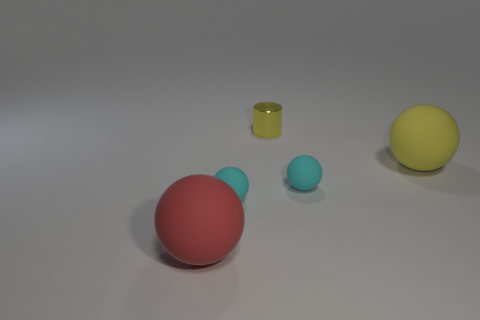Add 2 tiny cyan things. How many objects exist? 7 Subtract all gray balls. Subtract all red cubes. How many balls are left? 4 Subtract all balls. How many objects are left? 1 Subtract 0 red cylinders. How many objects are left? 5 Subtract all matte things. Subtract all small brown rubber objects. How many objects are left? 1 Add 2 big yellow matte balls. How many big yellow matte balls are left? 3 Add 5 large cyan matte cubes. How many large cyan matte cubes exist? 5 